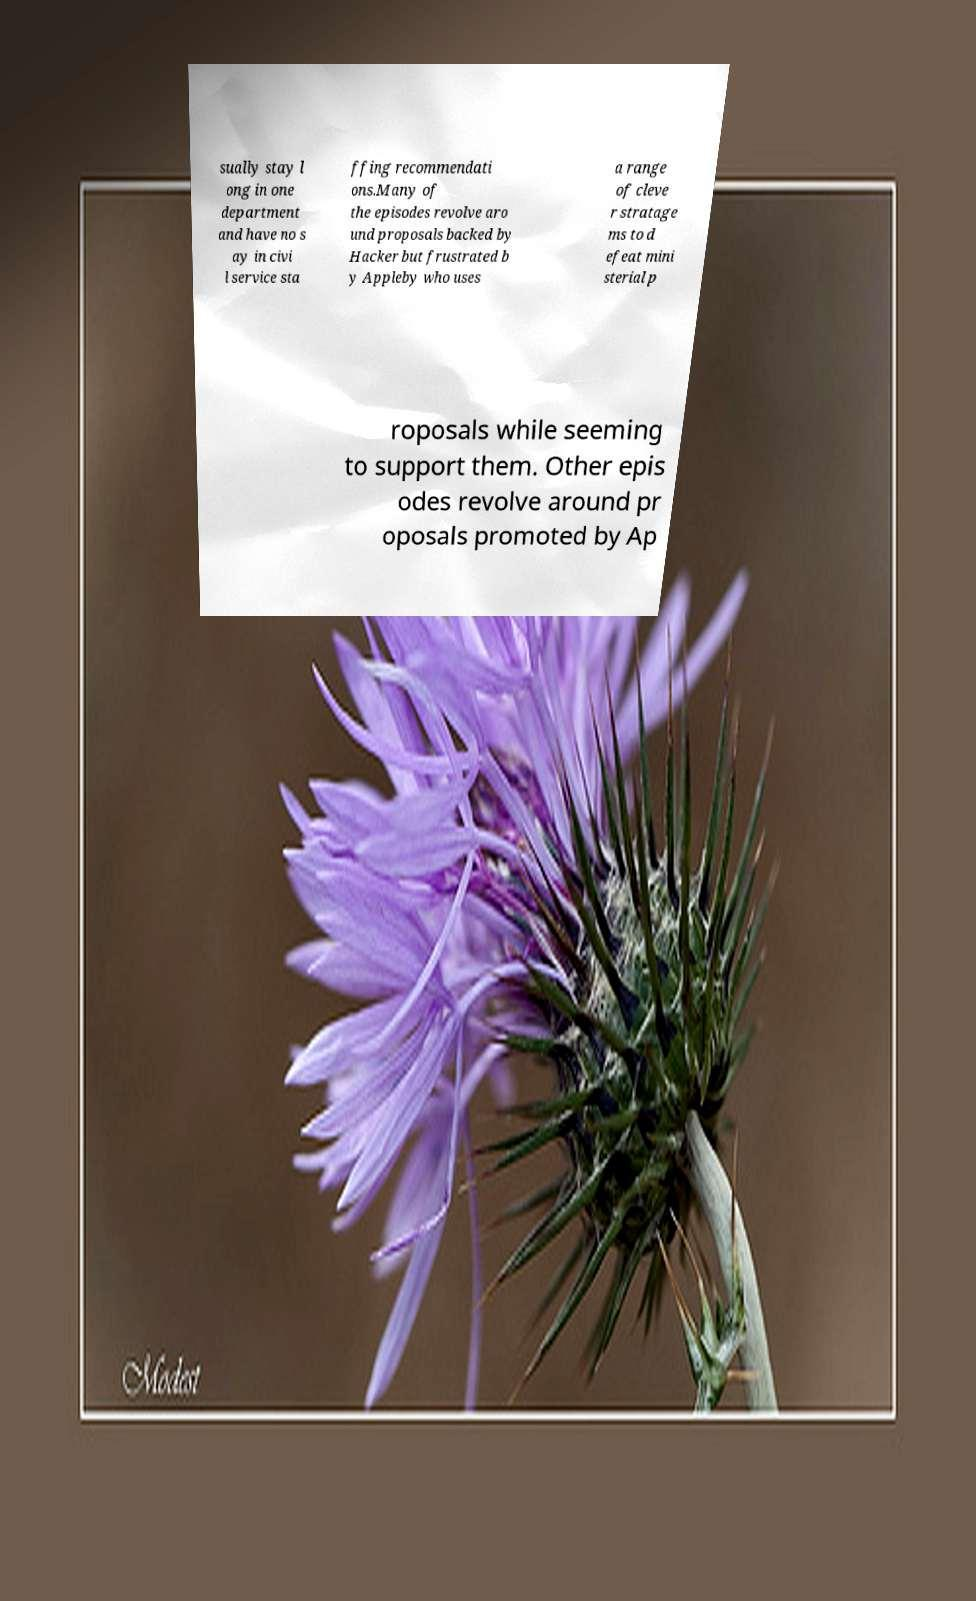I need the written content from this picture converted into text. Can you do that? sually stay l ong in one department and have no s ay in civi l service sta ffing recommendati ons.Many of the episodes revolve aro und proposals backed by Hacker but frustrated b y Appleby who uses a range of cleve r stratage ms to d efeat mini sterial p roposals while seeming to support them. Other epis odes revolve around pr oposals promoted by Ap 